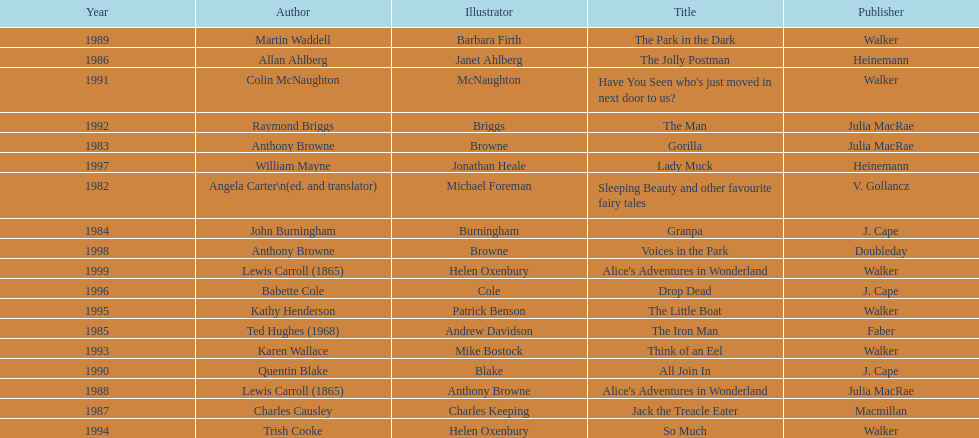How many titles did walker publish? 6. 